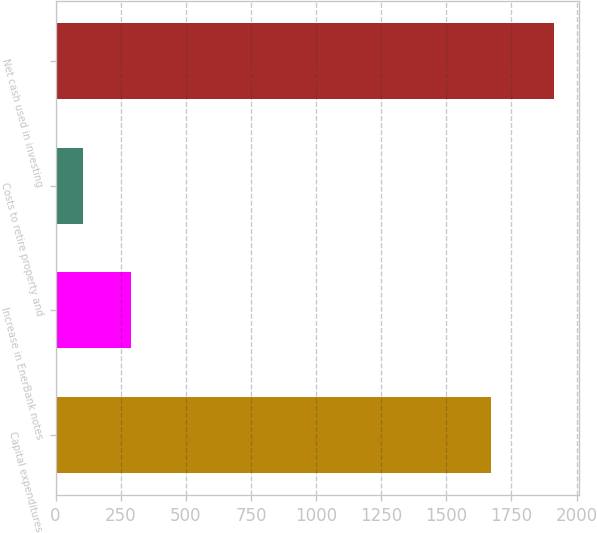Convert chart. <chart><loc_0><loc_0><loc_500><loc_500><bar_chart><fcel>Capital expenditures<fcel>Increase in EnerBank notes<fcel>Costs to retire property and<fcel>Net cash used in investing<nl><fcel>1672<fcel>287.8<fcel>107<fcel>1915<nl></chart> 